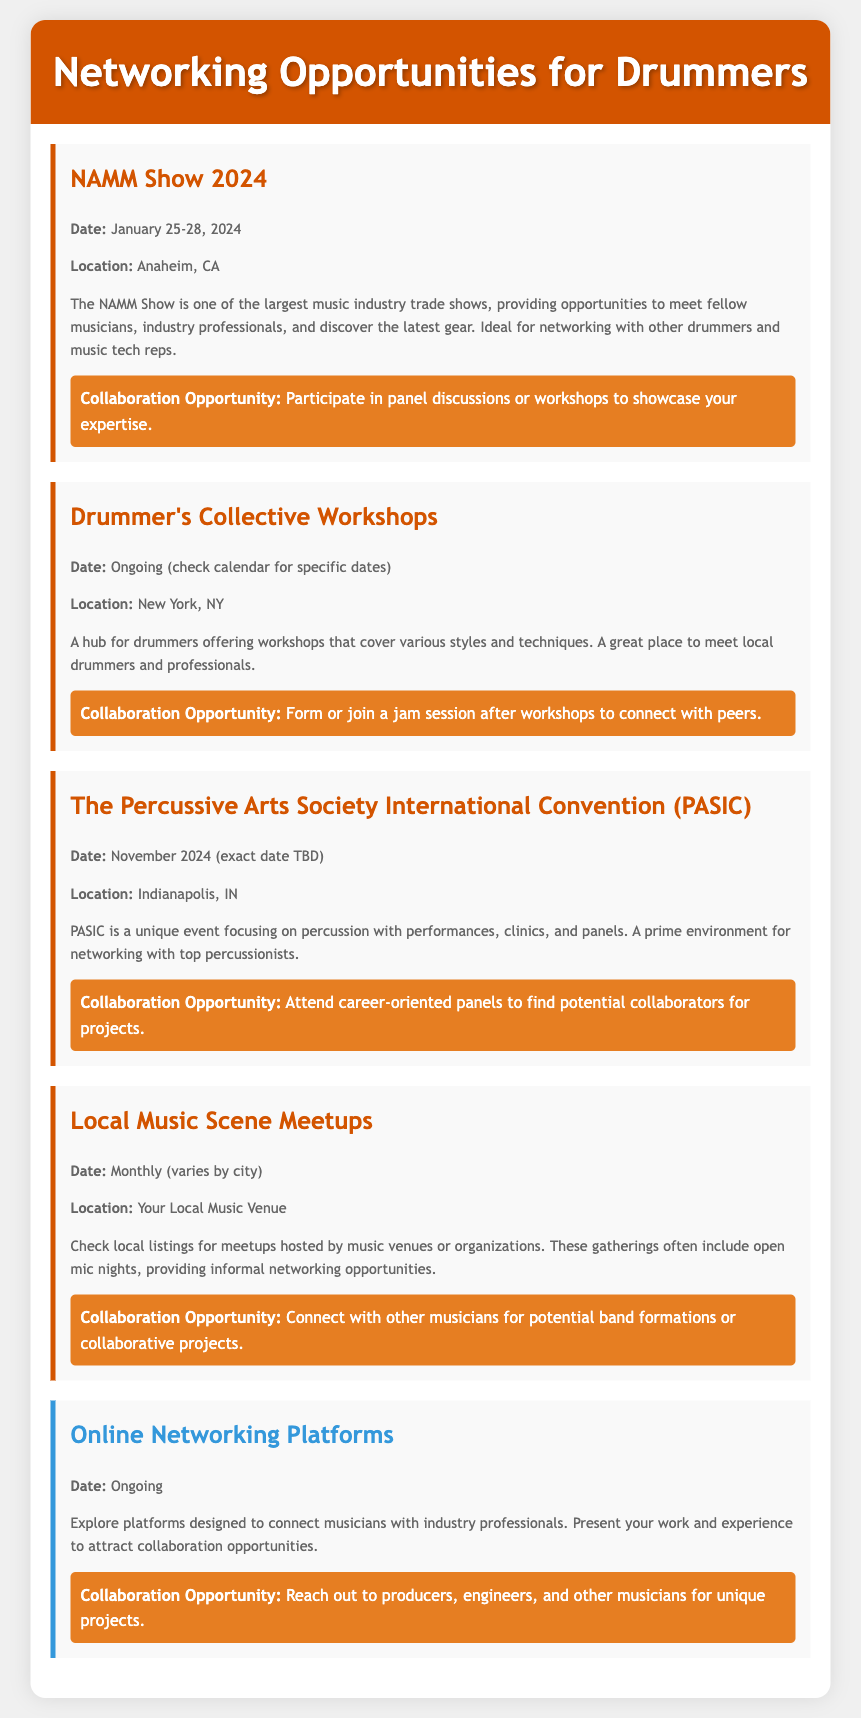What is the date of the NAMM Show 2024? The document states that the NAMM Show 2024 will be held from January 25-28, 2024.
Answer: January 25-28, 2024 Where is the Drummer's Collective Workshops located? The document indicates that the Drummer's Collective Workshops take place in New York, NY.
Answer: New York, NY What type of events are found at PASIC? The document describes PASIC as focusing on percussion with performances, clinics, and panels.
Answer: Performances, clinics, and panels What is one collaboration opportunity at Local Music Scene Meetups? The document suggests that a collaboration opportunity is to connect with other musicians for potential band formations or collaborative projects.
Answer: Connect with other musicians What is the ongoing date for Online Networking Platforms? The document states that Online Networking Platforms are ongoing, meaning there is no specific date.
Answer: Ongoing 